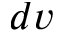<formula> <loc_0><loc_0><loc_500><loc_500>d v</formula> 